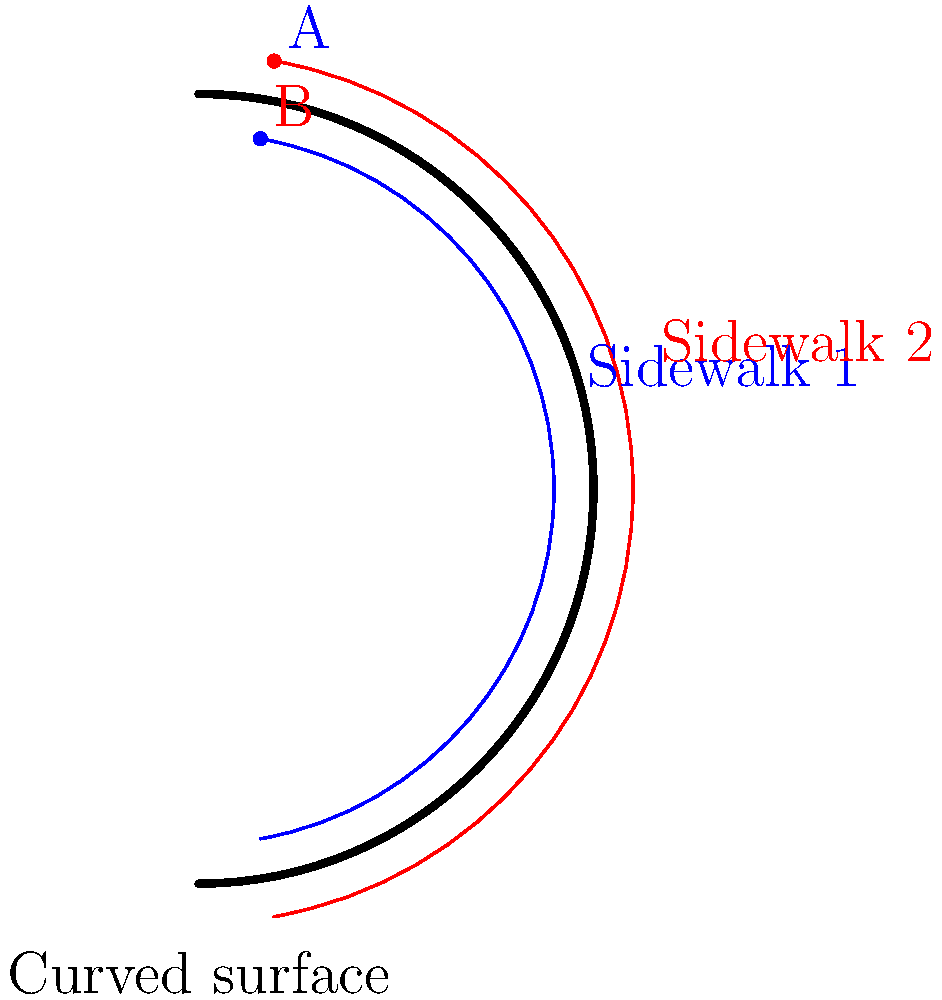In the East Hillside neighborhood of Duluth, you notice two parallel sidewalks following a curved street. If these sidewalks were extended indefinitely along the curved surface, would they intersect? If so, how many times? To answer this question, we need to consider the principles of Non-Euclidean geometry, specifically geometry on a curved surface:

1. In Euclidean geometry (flat space), parallel lines never intersect.

2. However, on a curved surface like the one shown in the diagram (which represents the curved street), the rules of Euclidean geometry no longer apply.

3. The sidewalks are represented by the blue and red curves on the surface. They appear parallel at first glance.

4. In Non-Euclidean geometry on a positively curved surface (like a sphere or the outer surface of a cylinder), parallel lines will eventually intersect.

5. The diagram shows a section of a cylindrical surface. If we extend this surface and the sidewalk lines, they would wrap around the cylinder.

6. As the sidewalks continue around the cylinder, they would meet at two points:
   a. Point A: Where the blue line intersects with the continuation of the red line.
   b. Point B: Where the red line intersects with the continuation of the blue line.

7. These intersection points would occur on opposite sides of the cylindrical surface.

Therefore, the parallel sidewalks would intersect twice if extended indefinitely along the curved surface.
Answer: Yes, they would intersect twice. 